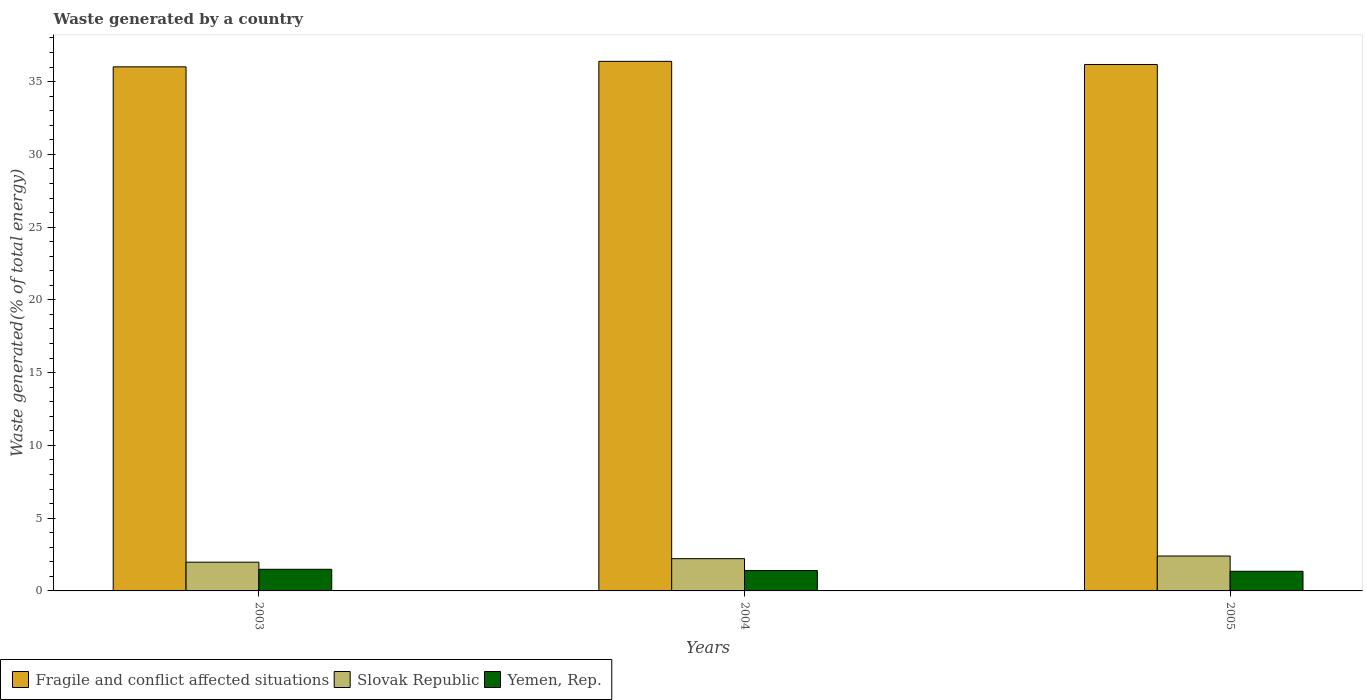How many different coloured bars are there?
Ensure brevity in your answer.  3. Are the number of bars per tick equal to the number of legend labels?
Your response must be concise. Yes. Are the number of bars on each tick of the X-axis equal?
Offer a terse response. Yes. How many bars are there on the 2nd tick from the left?
Provide a succinct answer. 3. What is the label of the 2nd group of bars from the left?
Keep it short and to the point. 2004. In how many cases, is the number of bars for a given year not equal to the number of legend labels?
Ensure brevity in your answer.  0. What is the total waste generated in Slovak Republic in 2005?
Offer a terse response. 2.4. Across all years, what is the maximum total waste generated in Yemen, Rep.?
Provide a short and direct response. 1.49. Across all years, what is the minimum total waste generated in Slovak Republic?
Ensure brevity in your answer.  1.97. In which year was the total waste generated in Yemen, Rep. maximum?
Your answer should be compact. 2003. What is the total total waste generated in Fragile and conflict affected situations in the graph?
Ensure brevity in your answer.  108.59. What is the difference between the total waste generated in Yemen, Rep. in 2003 and that in 2004?
Provide a short and direct response. 0.09. What is the difference between the total waste generated in Slovak Republic in 2005 and the total waste generated in Yemen, Rep. in 2003?
Provide a short and direct response. 0.91. What is the average total waste generated in Fragile and conflict affected situations per year?
Your answer should be compact. 36.2. In the year 2005, what is the difference between the total waste generated in Yemen, Rep. and total waste generated in Slovak Republic?
Provide a succinct answer. -1.05. In how many years, is the total waste generated in Fragile and conflict affected situations greater than 6 %?
Provide a short and direct response. 3. What is the ratio of the total waste generated in Fragile and conflict affected situations in 2003 to that in 2004?
Keep it short and to the point. 0.99. Is the total waste generated in Fragile and conflict affected situations in 2003 less than that in 2005?
Keep it short and to the point. Yes. What is the difference between the highest and the second highest total waste generated in Slovak Republic?
Your answer should be very brief. 0.18. What is the difference between the highest and the lowest total waste generated in Yemen, Rep.?
Ensure brevity in your answer.  0.14. Is the sum of the total waste generated in Yemen, Rep. in 2004 and 2005 greater than the maximum total waste generated in Slovak Republic across all years?
Your answer should be compact. Yes. What does the 3rd bar from the left in 2003 represents?
Give a very brief answer. Yemen, Rep. What does the 1st bar from the right in 2003 represents?
Offer a terse response. Yemen, Rep. Are all the bars in the graph horizontal?
Your answer should be very brief. No. How many years are there in the graph?
Your answer should be compact. 3. What is the difference between two consecutive major ticks on the Y-axis?
Give a very brief answer. 5. Are the values on the major ticks of Y-axis written in scientific E-notation?
Offer a very short reply. No. Does the graph contain any zero values?
Provide a succinct answer. No. Does the graph contain grids?
Make the answer very short. No. How many legend labels are there?
Offer a terse response. 3. What is the title of the graph?
Offer a very short reply. Waste generated by a country. What is the label or title of the X-axis?
Provide a short and direct response. Years. What is the label or title of the Y-axis?
Offer a very short reply. Waste generated(% of total energy). What is the Waste generated(% of total energy) of Fragile and conflict affected situations in 2003?
Your answer should be compact. 36.02. What is the Waste generated(% of total energy) of Slovak Republic in 2003?
Ensure brevity in your answer.  1.97. What is the Waste generated(% of total energy) in Yemen, Rep. in 2003?
Offer a very short reply. 1.49. What is the Waste generated(% of total energy) in Fragile and conflict affected situations in 2004?
Provide a succinct answer. 36.39. What is the Waste generated(% of total energy) of Slovak Republic in 2004?
Your response must be concise. 2.22. What is the Waste generated(% of total energy) of Yemen, Rep. in 2004?
Provide a short and direct response. 1.4. What is the Waste generated(% of total energy) in Fragile and conflict affected situations in 2005?
Offer a very short reply. 36.18. What is the Waste generated(% of total energy) in Slovak Republic in 2005?
Your answer should be very brief. 2.4. What is the Waste generated(% of total energy) in Yemen, Rep. in 2005?
Your response must be concise. 1.35. Across all years, what is the maximum Waste generated(% of total energy) in Fragile and conflict affected situations?
Your answer should be compact. 36.39. Across all years, what is the maximum Waste generated(% of total energy) of Slovak Republic?
Offer a very short reply. 2.4. Across all years, what is the maximum Waste generated(% of total energy) of Yemen, Rep.?
Make the answer very short. 1.49. Across all years, what is the minimum Waste generated(% of total energy) of Fragile and conflict affected situations?
Ensure brevity in your answer.  36.02. Across all years, what is the minimum Waste generated(% of total energy) of Slovak Republic?
Keep it short and to the point. 1.97. Across all years, what is the minimum Waste generated(% of total energy) in Yemen, Rep.?
Provide a short and direct response. 1.35. What is the total Waste generated(% of total energy) of Fragile and conflict affected situations in the graph?
Ensure brevity in your answer.  108.59. What is the total Waste generated(% of total energy) in Slovak Republic in the graph?
Provide a succinct answer. 6.59. What is the total Waste generated(% of total energy) of Yemen, Rep. in the graph?
Offer a terse response. 4.24. What is the difference between the Waste generated(% of total energy) in Fragile and conflict affected situations in 2003 and that in 2004?
Your answer should be compact. -0.38. What is the difference between the Waste generated(% of total energy) in Slovak Republic in 2003 and that in 2004?
Provide a succinct answer. -0.24. What is the difference between the Waste generated(% of total energy) of Yemen, Rep. in 2003 and that in 2004?
Offer a very short reply. 0.09. What is the difference between the Waste generated(% of total energy) in Fragile and conflict affected situations in 2003 and that in 2005?
Offer a very short reply. -0.16. What is the difference between the Waste generated(% of total energy) in Slovak Republic in 2003 and that in 2005?
Offer a very short reply. -0.42. What is the difference between the Waste generated(% of total energy) of Yemen, Rep. in 2003 and that in 2005?
Give a very brief answer. 0.14. What is the difference between the Waste generated(% of total energy) of Fragile and conflict affected situations in 2004 and that in 2005?
Your response must be concise. 0.22. What is the difference between the Waste generated(% of total energy) in Slovak Republic in 2004 and that in 2005?
Offer a terse response. -0.18. What is the difference between the Waste generated(% of total energy) in Yemen, Rep. in 2004 and that in 2005?
Ensure brevity in your answer.  0.05. What is the difference between the Waste generated(% of total energy) of Fragile and conflict affected situations in 2003 and the Waste generated(% of total energy) of Slovak Republic in 2004?
Your answer should be compact. 33.8. What is the difference between the Waste generated(% of total energy) of Fragile and conflict affected situations in 2003 and the Waste generated(% of total energy) of Yemen, Rep. in 2004?
Provide a short and direct response. 34.62. What is the difference between the Waste generated(% of total energy) in Slovak Republic in 2003 and the Waste generated(% of total energy) in Yemen, Rep. in 2004?
Your response must be concise. 0.57. What is the difference between the Waste generated(% of total energy) in Fragile and conflict affected situations in 2003 and the Waste generated(% of total energy) in Slovak Republic in 2005?
Your answer should be compact. 33.62. What is the difference between the Waste generated(% of total energy) of Fragile and conflict affected situations in 2003 and the Waste generated(% of total energy) of Yemen, Rep. in 2005?
Give a very brief answer. 34.67. What is the difference between the Waste generated(% of total energy) in Slovak Republic in 2003 and the Waste generated(% of total energy) in Yemen, Rep. in 2005?
Provide a succinct answer. 0.63. What is the difference between the Waste generated(% of total energy) in Fragile and conflict affected situations in 2004 and the Waste generated(% of total energy) in Slovak Republic in 2005?
Make the answer very short. 33.99. What is the difference between the Waste generated(% of total energy) in Fragile and conflict affected situations in 2004 and the Waste generated(% of total energy) in Yemen, Rep. in 2005?
Provide a succinct answer. 35.04. What is the difference between the Waste generated(% of total energy) of Slovak Republic in 2004 and the Waste generated(% of total energy) of Yemen, Rep. in 2005?
Provide a short and direct response. 0.87. What is the average Waste generated(% of total energy) in Fragile and conflict affected situations per year?
Offer a very short reply. 36.2. What is the average Waste generated(% of total energy) of Slovak Republic per year?
Make the answer very short. 2.2. What is the average Waste generated(% of total energy) of Yemen, Rep. per year?
Provide a succinct answer. 1.41. In the year 2003, what is the difference between the Waste generated(% of total energy) in Fragile and conflict affected situations and Waste generated(% of total energy) in Slovak Republic?
Provide a short and direct response. 34.04. In the year 2003, what is the difference between the Waste generated(% of total energy) of Fragile and conflict affected situations and Waste generated(% of total energy) of Yemen, Rep.?
Provide a short and direct response. 34.53. In the year 2003, what is the difference between the Waste generated(% of total energy) in Slovak Republic and Waste generated(% of total energy) in Yemen, Rep.?
Make the answer very short. 0.49. In the year 2004, what is the difference between the Waste generated(% of total energy) in Fragile and conflict affected situations and Waste generated(% of total energy) in Slovak Republic?
Provide a short and direct response. 34.18. In the year 2004, what is the difference between the Waste generated(% of total energy) in Fragile and conflict affected situations and Waste generated(% of total energy) in Yemen, Rep.?
Make the answer very short. 34.99. In the year 2004, what is the difference between the Waste generated(% of total energy) of Slovak Republic and Waste generated(% of total energy) of Yemen, Rep.?
Your answer should be compact. 0.82. In the year 2005, what is the difference between the Waste generated(% of total energy) of Fragile and conflict affected situations and Waste generated(% of total energy) of Slovak Republic?
Offer a very short reply. 33.78. In the year 2005, what is the difference between the Waste generated(% of total energy) in Fragile and conflict affected situations and Waste generated(% of total energy) in Yemen, Rep.?
Provide a short and direct response. 34.83. In the year 2005, what is the difference between the Waste generated(% of total energy) in Slovak Republic and Waste generated(% of total energy) in Yemen, Rep.?
Offer a very short reply. 1.05. What is the ratio of the Waste generated(% of total energy) in Slovak Republic in 2003 to that in 2004?
Provide a succinct answer. 0.89. What is the ratio of the Waste generated(% of total energy) in Yemen, Rep. in 2003 to that in 2004?
Offer a very short reply. 1.06. What is the ratio of the Waste generated(% of total energy) in Fragile and conflict affected situations in 2003 to that in 2005?
Provide a succinct answer. 1. What is the ratio of the Waste generated(% of total energy) of Slovak Republic in 2003 to that in 2005?
Provide a short and direct response. 0.82. What is the ratio of the Waste generated(% of total energy) of Yemen, Rep. in 2003 to that in 2005?
Offer a terse response. 1.1. What is the ratio of the Waste generated(% of total energy) in Fragile and conflict affected situations in 2004 to that in 2005?
Your answer should be very brief. 1.01. What is the ratio of the Waste generated(% of total energy) in Slovak Republic in 2004 to that in 2005?
Offer a very short reply. 0.92. What is the ratio of the Waste generated(% of total energy) of Yemen, Rep. in 2004 to that in 2005?
Keep it short and to the point. 1.04. What is the difference between the highest and the second highest Waste generated(% of total energy) of Fragile and conflict affected situations?
Provide a succinct answer. 0.22. What is the difference between the highest and the second highest Waste generated(% of total energy) in Slovak Republic?
Provide a succinct answer. 0.18. What is the difference between the highest and the second highest Waste generated(% of total energy) in Yemen, Rep.?
Offer a very short reply. 0.09. What is the difference between the highest and the lowest Waste generated(% of total energy) of Fragile and conflict affected situations?
Provide a short and direct response. 0.38. What is the difference between the highest and the lowest Waste generated(% of total energy) of Slovak Republic?
Your answer should be very brief. 0.42. What is the difference between the highest and the lowest Waste generated(% of total energy) of Yemen, Rep.?
Your response must be concise. 0.14. 